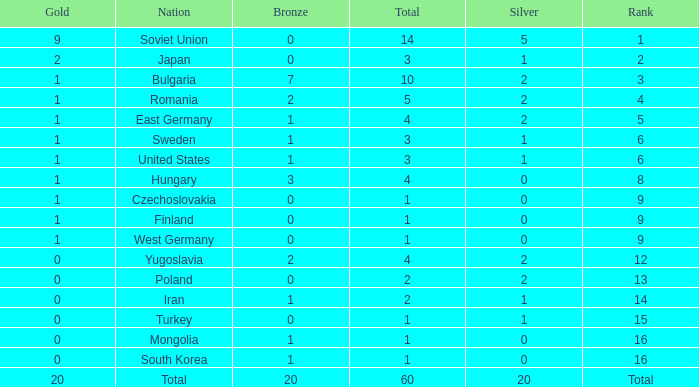What is the total number of golds having a total of 1, bronzes of 0, and from West Germany? 1.0. 